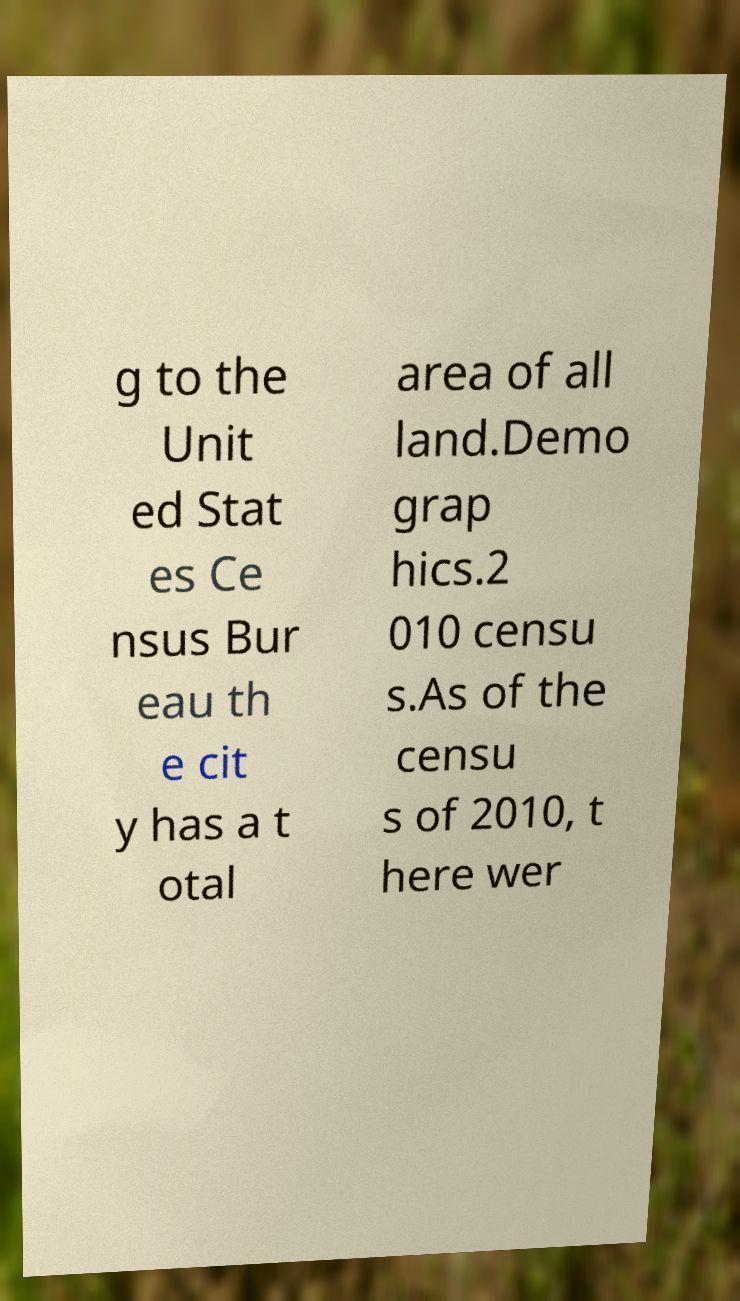There's text embedded in this image that I need extracted. Can you transcribe it verbatim? g to the Unit ed Stat es Ce nsus Bur eau th e cit y has a t otal area of all land.Demo grap hics.2 010 censu s.As of the censu s of 2010, t here wer 